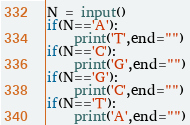Convert code to text. <code><loc_0><loc_0><loc_500><loc_500><_Python_>N = input()
if(N=='A'):
	print('T',end="")
if(N=='C'):
	print('G',end="")
if(N=='G'):
	print('C',end="")
if(N=='T'):
	print('A',end="")</code> 